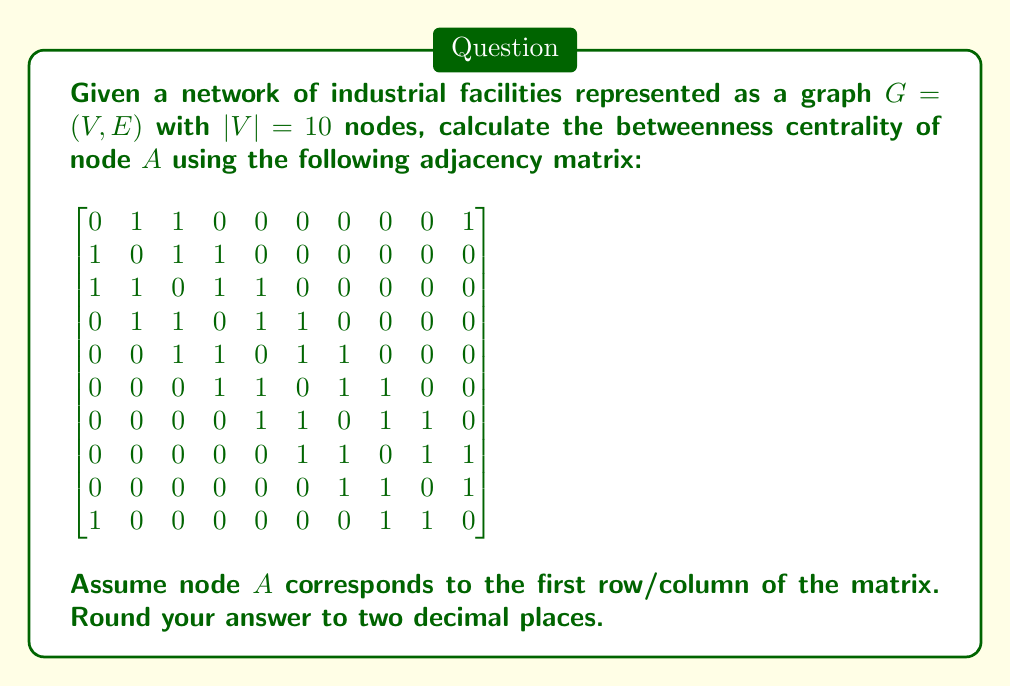Give your solution to this math problem. To calculate the betweenness centrality of node $A$, we need to follow these steps:

1) First, we need to find all shortest paths between all pairs of nodes.
2) Then, we count how many of these shortest paths pass through node $A$.
3) Finally, we calculate the betweenness centrality using the formula:

   $$C_B(v) = \sum_{s\neq v\neq t} \frac{\sigma_{st}(v)}{\sigma_{st}}$$

   where $\sigma_{st}$ is the total number of shortest paths from node $s$ to node $t$, and $\sigma_{st}(v)$ is the number of those paths that pass through $v$.

Let's go through this process:

1) Using the Floyd-Warshall algorithm or Dijkstra's algorithm for each node, we can find all shortest paths.

2) Counting the shortest paths through $A$:
   - $B$ to $J$: 1 path through $A$ out of 1 total (B-A-J)
   - $C$ to $J$: 1 path through $A$ out of 1 total (C-A-J)
   - $D$ to $J$: 1 path through $A$ out of 2 total (D-B-A-J and D-H-J)
   - $E$ to $J$: 1 path through $A$ out of 2 total (E-C-A-J and E-G-H-J)
   - $F$ to $J$: 0 paths through $A$ out of 1 total
   - $G$ to $J$: 0 paths through $A$ out of 1 total
   - $H$ to $B$: 1 path through $A$ out of 1 total (H-J-A-B)
   - $I$ to $B$: 1 path through $A$ out of 1 total (I-J-A-B)
   - $I$ to $C$: 1 path through $A$ out of 1 total (I-J-A-C)

3) Calculating betweenness centrality:

   $$C_B(A) = 1 + 1 + \frac{1}{2} + \frac{1}{2} + 0 + 0 + 1 + 1 + 1 = 6$$

4) Normalizing:
   The maximum possible betweenness for a node in a network with $n$ nodes is $(n-1)(n-2)/2$, which is 36 in this case.

   Normalized betweenness centrality: $6/36 = 0.1666667$

Rounding to two decimal places: 0.17
Answer: 0.17 